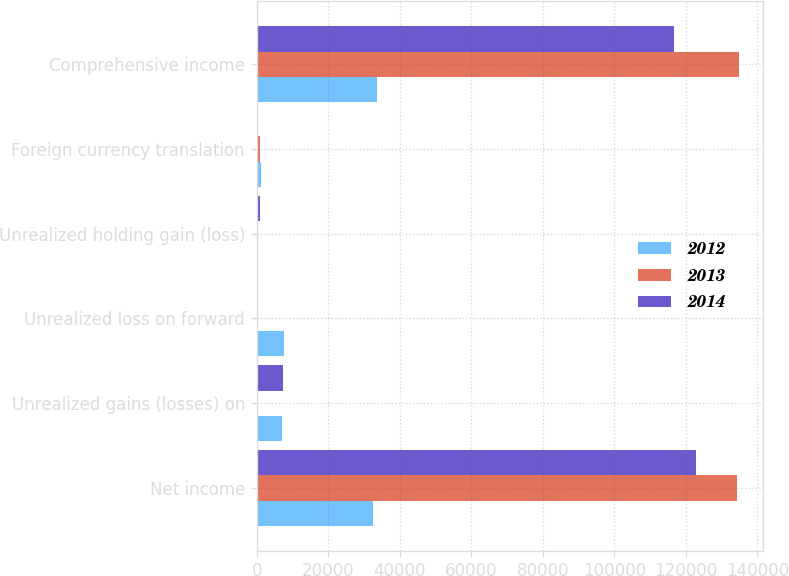Convert chart. <chart><loc_0><loc_0><loc_500><loc_500><stacked_bar_chart><ecel><fcel>Net income<fcel>Unrealized gains (losses) on<fcel>Unrealized loss on forward<fcel>Unrealized holding gain (loss)<fcel>Foreign currency translation<fcel>Comprehensive income<nl><fcel>2012<fcel>32429<fcel>7190<fcel>7699<fcel>425<fcel>1318<fcel>33663<nl><fcel>2013<fcel>134358<fcel>118<fcel>0<fcel>456<fcel>882<fcel>134902<nl><fcel>2014<fcel>122904<fcel>7241<fcel>0<fcel>887<fcel>242<fcel>116792<nl></chart> 